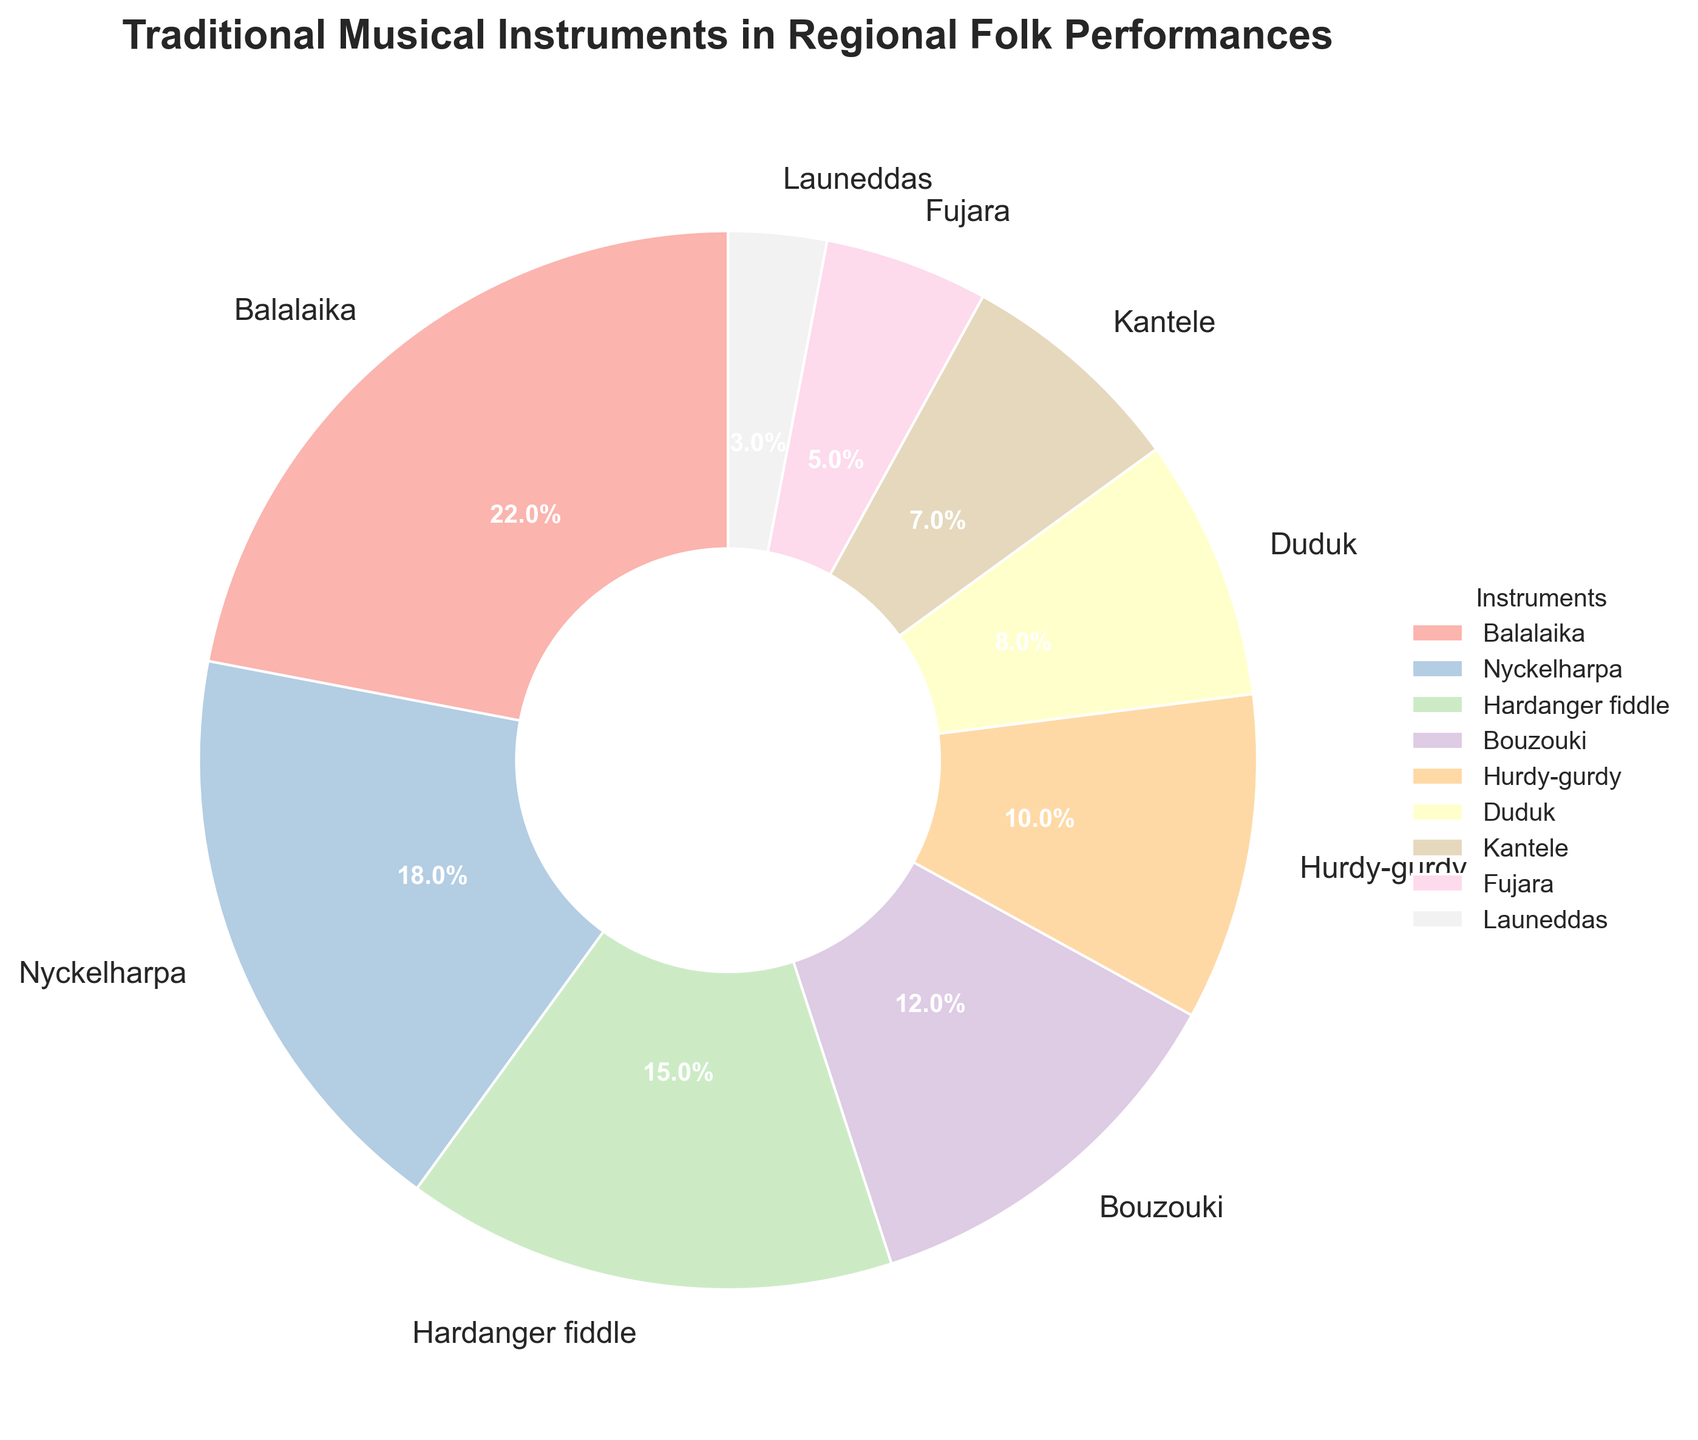What's the most commonly used traditional musical instrument in regional folk performances? The pie chart shows the instrument with the largest percentage slice which represents the most commonly used instrument. The Balalaika has the largest slice at 22%.
Answer: Balalaika Which instrument has the smallest usage percentage in regional folk performances? By observing the pie chart, the smallest slice represents the instrument with the least usage. The Launeddas has the smallest percentage at 3%.
Answer: Launeddas What's the difference in percentage between the Balalaika and the Hurdy-gurdy? The Balalaika is 22% and the Hurdy-gurdy is 10%. The difference is calculated as 22% - 10% = 12%.
Answer: 12% How many instruments have a usage percentage of 10% or higher? By counting the slices in the pie chart that are 10% or higher: Balalaika (22%), Nyckelharpa (18%), Hardanger fiddle (15%), Bouzouki (12%), Hurdy-gurdy (10%). There are 5 instruments.
Answer: 5 Which instrument has a slightly higher percentage usage than the Kantele? The Kantele has a 7% usage. The next instrument with a slightly higher usage is the Duduk with 8%.
Answer: Duduk What is the combined percentage of the Nyckelharpa and Hardanger fiddle? The Nyckelharpa is 18% and the Hardanger fiddle is 15%. The combined percentage is 18% + 15% = 33%.
Answer: 33% Which instrument is used less frequently than the Bouzouki but more frequently than the Fujara? The Bouzouki has 12%, and the Fujara has 5%. The instrument that falls in between these percentages is the Kantele with 7%.
Answer: Kantele How much more is the usage percentage of the Hardanger fiddle compared to the Launeddas? The Hardanger fiddle has 15%, and the Launeddas has 3%. The difference is 15% - 3% = 12%.
Answer: 12% Which three instruments have the highest usage percentages? Observing the slices of the pie chart, the three largest slices correspond to the Balalaika (22%), Nyckelharpa (18%), and Hardanger fiddle (15%).
Answer: Balalaika, Nyckelharpa, Hardanger fiddle 